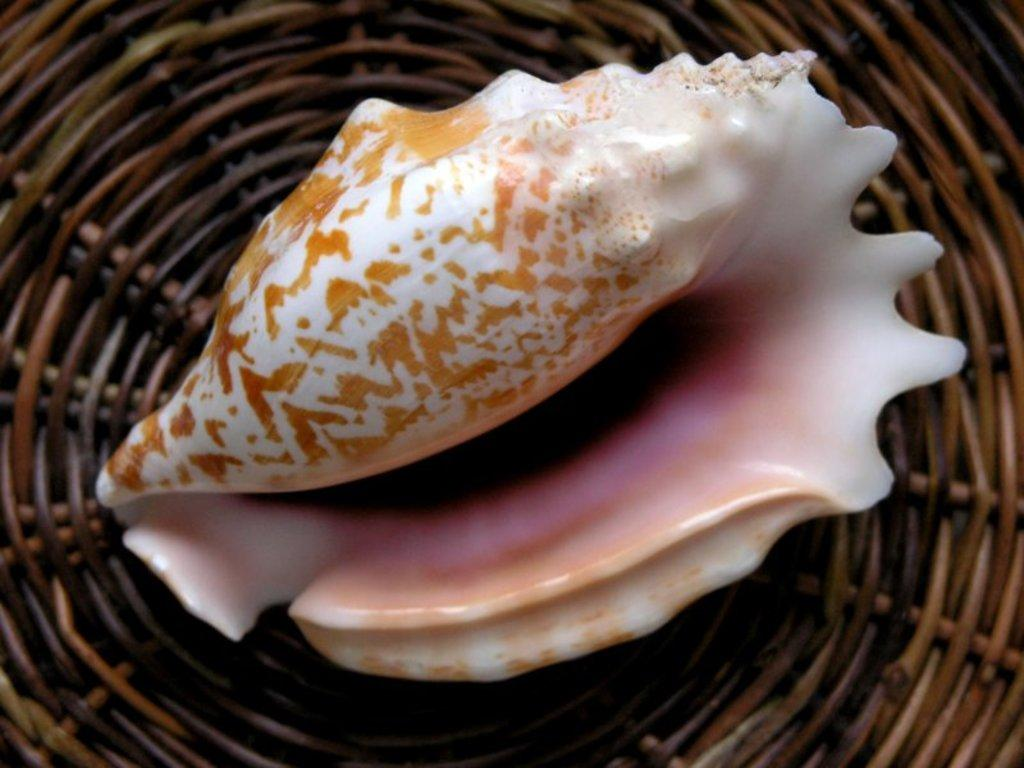What is the main subject of the image? The main subject of the image is a seashell. Where is the seashell located in relation to other objects in the image? The seashell is placed on an object, and both the seashell and the object are in the middle of the image. What type of crack can be seen on the seashell in the image? There is no crack visible on the seashell in the image. Are there any worms crawling on the seashell in the image? There are no worms present in the image. 